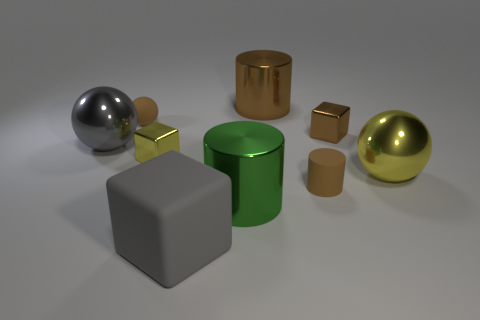Subtract all big spheres. How many spheres are left? 1 Add 1 tiny brown cubes. How many objects exist? 10 Subtract all brown cylinders. How many cylinders are left? 1 Subtract all balls. How many objects are left? 6 Subtract 1 spheres. How many spheres are left? 2 Subtract all brown cubes. Subtract all yellow cylinders. How many cubes are left? 2 Subtract all blue spheres. How many purple blocks are left? 0 Subtract all brown metal objects. Subtract all tiny cylinders. How many objects are left? 6 Add 3 brown cubes. How many brown cubes are left? 4 Add 9 gray matte blocks. How many gray matte blocks exist? 10 